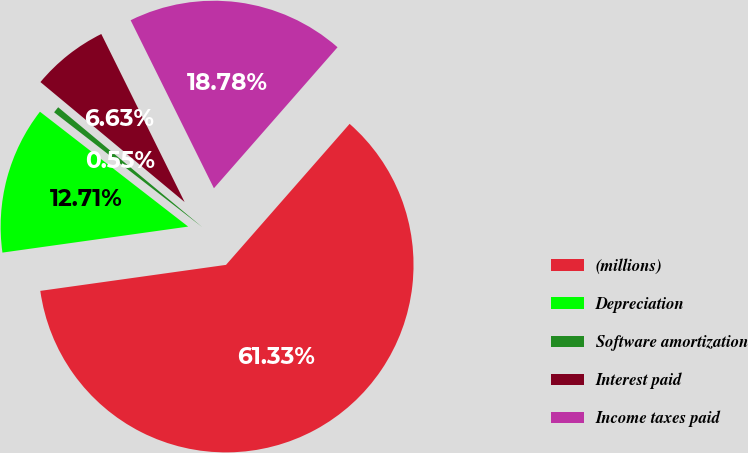Convert chart to OTSL. <chart><loc_0><loc_0><loc_500><loc_500><pie_chart><fcel>(millions)<fcel>Depreciation<fcel>Software amortization<fcel>Interest paid<fcel>Income taxes paid<nl><fcel>61.33%<fcel>12.71%<fcel>0.55%<fcel>6.63%<fcel>18.78%<nl></chart> 